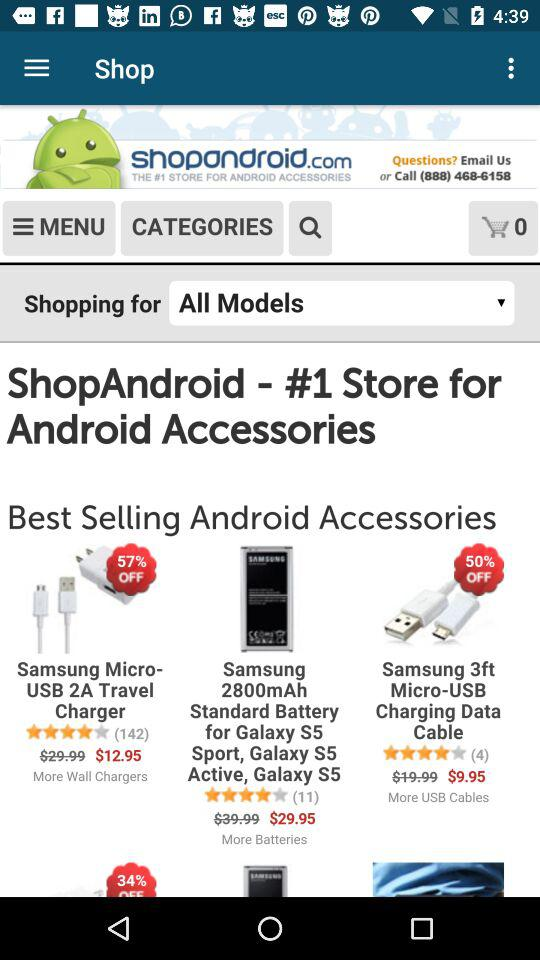How many items are in the cart? There is 0 item in the cart. 